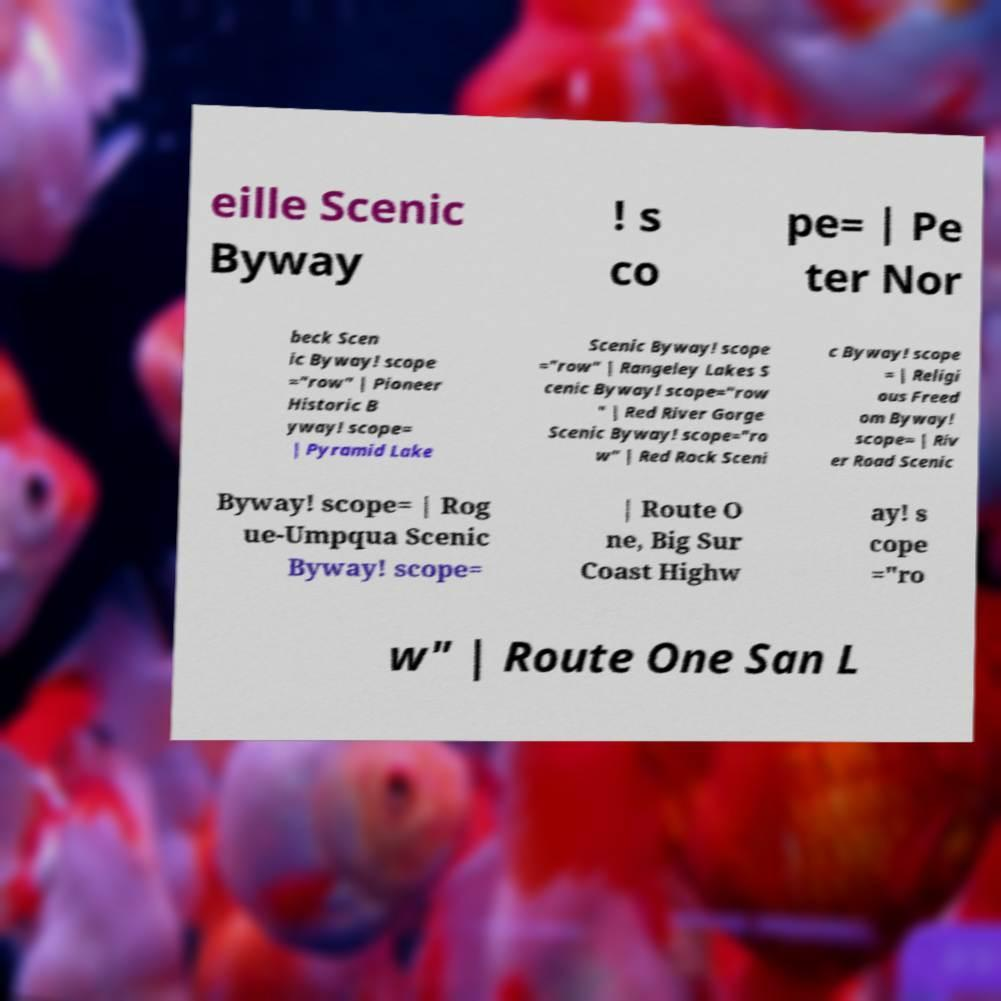What messages or text are displayed in this image? I need them in a readable, typed format. eille Scenic Byway ! s co pe= | Pe ter Nor beck Scen ic Byway! scope ="row" | Pioneer Historic B yway! scope= | Pyramid Lake Scenic Byway! scope ="row" | Rangeley Lakes S cenic Byway! scope="row " | Red River Gorge Scenic Byway! scope="ro w" | Red Rock Sceni c Byway! scope = | Religi ous Freed om Byway! scope= | Riv er Road Scenic Byway! scope= | Rog ue-Umpqua Scenic Byway! scope= | Route O ne, Big Sur Coast Highw ay! s cope ="ro w" | Route One San L 